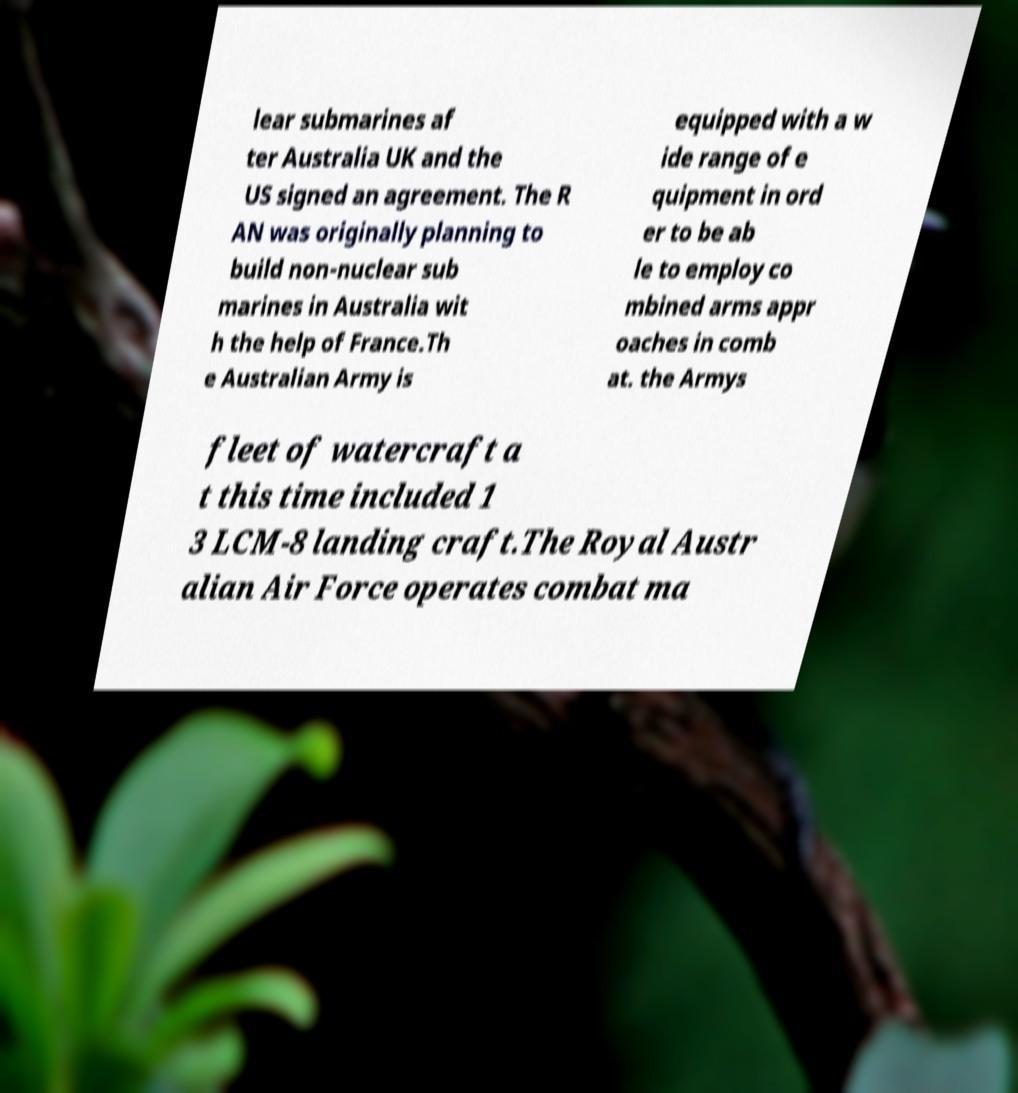Please identify and transcribe the text found in this image. lear submarines af ter Australia UK and the US signed an agreement. The R AN was originally planning to build non-nuclear sub marines in Australia wit h the help of France.Th e Australian Army is equipped with a w ide range of e quipment in ord er to be ab le to employ co mbined arms appr oaches in comb at. the Armys fleet of watercraft a t this time included 1 3 LCM-8 landing craft.The Royal Austr alian Air Force operates combat ma 